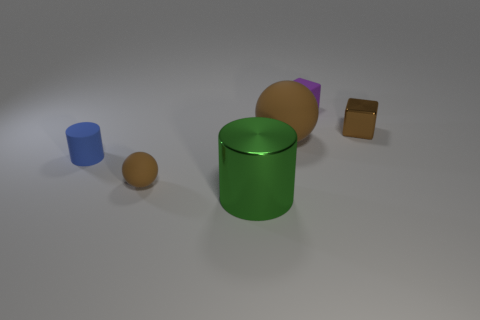There is a brown metallic object; is it the same size as the metal thing that is on the left side of the small purple matte block? The brown metallic object appears to be a small cube. It is smaller when compared to the cylinder on the left side of the purple block. The cylinder is taller and has a larger diameter than the cube. 